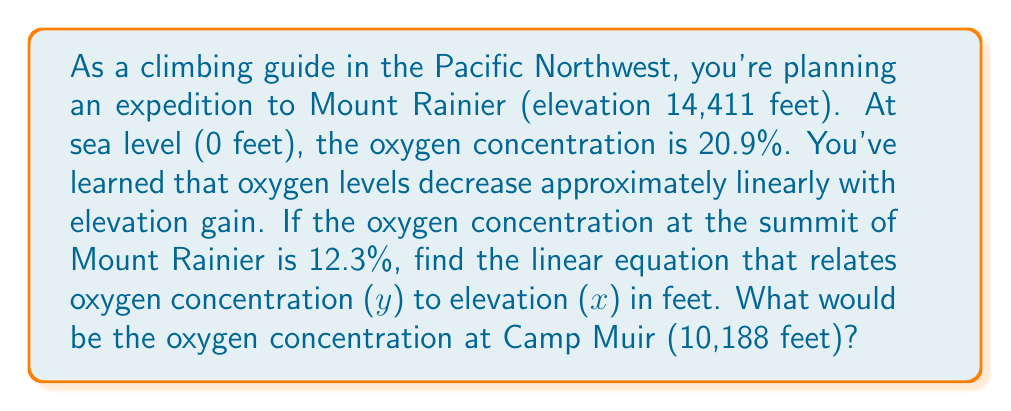Can you answer this question? To solve this problem, we'll use the point-slope form of a linear equation:

$y - y_1 = m(x - x_1)$

Where $m$ is the slope, and $(x_1, y_1)$ is a known point on the line.

1. Find the slope:
   We have two points: (0, 20.9) and (14411, 12.3)
   
   $m = \frac{y_2 - y_1}{x_2 - x_1} = \frac{12.3 - 20.9}{14411 - 0} = \frac{-8.6}{14411} \approx -0.0005968$

2. Use the point-slope form with (0, 20.9):
   $y - 20.9 = -0.0005968(x - 0)$

3. Simplify to slope-intercept form:
   $y = -0.0005968x + 20.9$

This is the linear equation relating oxygen concentration (y) to elevation (x).

4. To find the oxygen concentration at Camp Muir (10,188 feet):
   $y = -0.0005968(10188) + 20.9$
   $y = -6.0802 + 20.9 = 14.8198$

Therefore, the oxygen concentration at Camp Muir is approximately 14.82%.
Answer: The linear equation is $y = -0.0005968x + 20.9$, where $y$ is the oxygen concentration (%) and $x$ is the elevation (feet).

The oxygen concentration at Camp Muir (10,188 feet) is approximately 14.82%. 